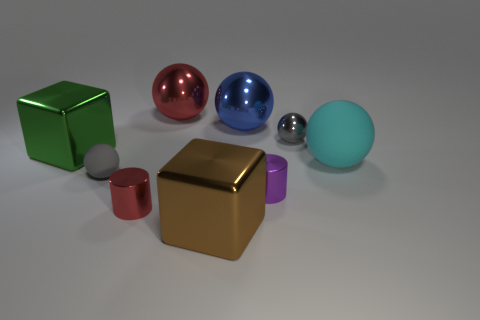Subtract 2 spheres. How many spheres are left? 3 Subtract all blue spheres. How many spheres are left? 4 Subtract all cyan balls. How many balls are left? 4 Subtract all yellow balls. Subtract all brown cubes. How many balls are left? 5 Subtract all blocks. How many objects are left? 7 Subtract 1 red spheres. How many objects are left? 8 Subtract all large brown things. Subtract all cyan rubber spheres. How many objects are left? 7 Add 9 large red shiny objects. How many large red shiny objects are left? 10 Add 1 tiny red metal things. How many tiny red metal things exist? 2 